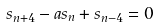Convert formula to latex. <formula><loc_0><loc_0><loc_500><loc_500>s _ { n + 4 } - a s _ { n } + s _ { n - 4 } = 0</formula> 